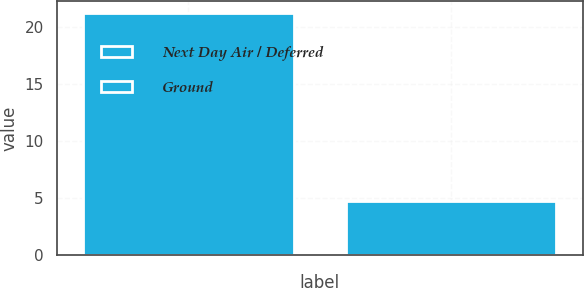Convert chart. <chart><loc_0><loc_0><loc_500><loc_500><bar_chart><fcel>Next Day Air / Deferred<fcel>Ground<nl><fcel>21.2<fcel>4.7<nl></chart> 